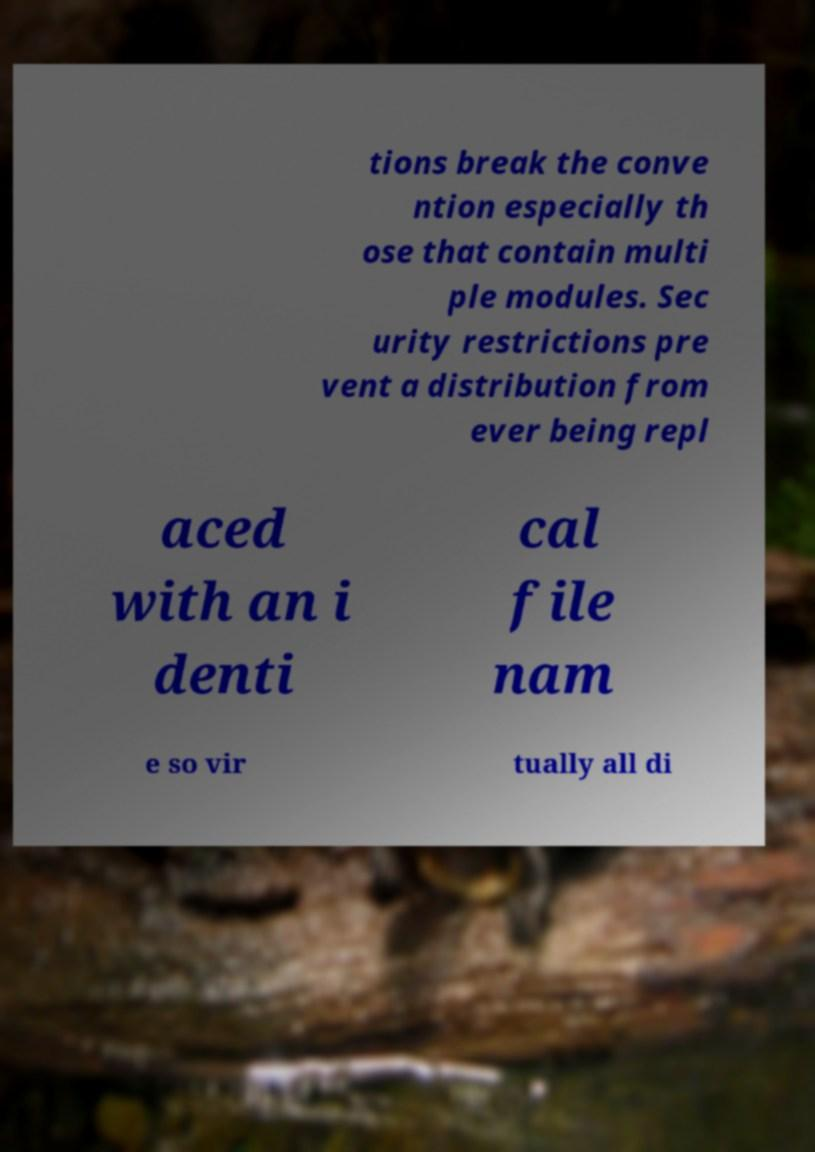Can you read and provide the text displayed in the image?This photo seems to have some interesting text. Can you extract and type it out for me? tions break the conve ntion especially th ose that contain multi ple modules. Sec urity restrictions pre vent a distribution from ever being repl aced with an i denti cal file nam e so vir tually all di 